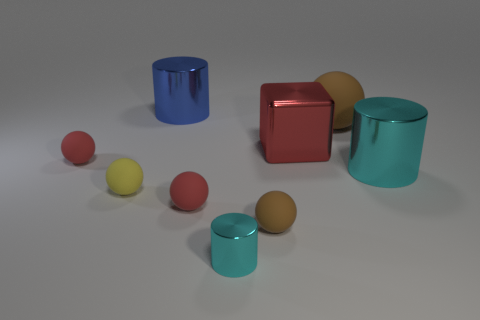How many cyan cylinders must be subtracted to get 1 cyan cylinders? 1 Subtract all purple balls. Subtract all brown cylinders. How many balls are left? 5 Subtract all cylinders. How many objects are left? 6 Subtract 0 green blocks. How many objects are left? 9 Subtract all green metallic cylinders. Subtract all large brown objects. How many objects are left? 8 Add 1 tiny red matte balls. How many tiny red matte balls are left? 3 Add 4 small brown spheres. How many small brown spheres exist? 5 